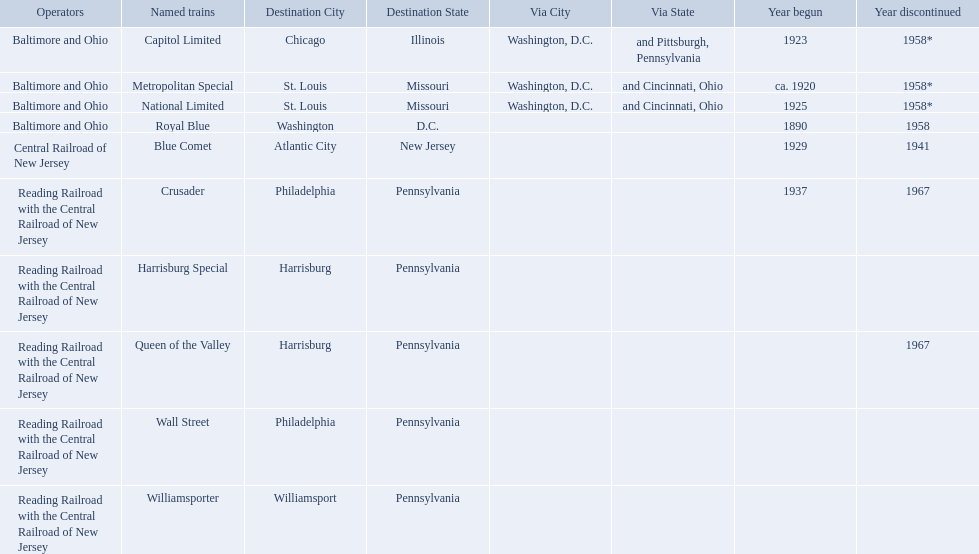What destinations are listed from the central railroad of new jersey terminal? Chicago, Illinois via Washington, D.C. and Pittsburgh, Pennsylvania, St. Louis, Missouri via Washington, D.C. and Cincinnati, Ohio, St. Louis, Missouri via Washington, D.C. and Cincinnati, Ohio, Washington, D.C., Atlantic City, New Jersey, Philadelphia, Pennsylvania, Harrisburg, Pennsylvania, Harrisburg, Pennsylvania, Philadelphia, Pennsylvania, Williamsport, Pennsylvania. Which of these destinations is listed first? Chicago, Illinois via Washington, D.C. and Pittsburgh, Pennsylvania. What are the destinations of the central railroad of new jersey terminal? Chicago, Illinois via Washington, D.C. and Pittsburgh, Pennsylvania, St. Louis, Missouri via Washington, D.C. and Cincinnati, Ohio, St. Louis, Missouri via Washington, D.C. and Cincinnati, Ohio, Washington, D.C., Atlantic City, New Jersey, Philadelphia, Pennsylvania, Harrisburg, Pennsylvania, Harrisburg, Pennsylvania, Philadelphia, Pennsylvania, Williamsport, Pennsylvania. Which of these destinations is at the top of the list? Chicago, Illinois via Washington, D.C. and Pittsburgh, Pennsylvania. Would you mind parsing the complete table? {'header': ['Operators', 'Named trains', 'Destination City', 'Destination State', 'Via City', 'Via State', 'Year begun', 'Year discontinued'], 'rows': [['Baltimore and Ohio', 'Capitol Limited', 'Chicago', 'Illinois', 'Washington, D.C.', 'and Pittsburgh, Pennsylvania', '1923', '1958*'], ['Baltimore and Ohio', 'Metropolitan Special', 'St. Louis', 'Missouri', 'Washington, D.C.', 'and Cincinnati, Ohio', 'ca. 1920', '1958*'], ['Baltimore and Ohio', 'National Limited', 'St. Louis', 'Missouri', 'Washington, D.C.', 'and Cincinnati, Ohio', '1925', '1958*'], ['Baltimore and Ohio', 'Royal Blue', 'Washington', 'D.C.', '', '', '1890', '1958'], ['Central Railroad of New Jersey', 'Blue Comet', 'Atlantic City', 'New Jersey', '', '', '1929', '1941'], ['Reading Railroad with the Central Railroad of New Jersey', 'Crusader', 'Philadelphia', 'Pennsylvania', '', '', '1937', '1967'], ['Reading Railroad with the Central Railroad of New Jersey', 'Harrisburg Special', 'Harrisburg', 'Pennsylvania', '', '', '', ''], ['Reading Railroad with the Central Railroad of New Jersey', 'Queen of the Valley', 'Harrisburg', 'Pennsylvania', '', '', '', '1967'], ['Reading Railroad with the Central Railroad of New Jersey', 'Wall Street', 'Philadelphia', 'Pennsylvania', '', '', '', ''], ['Reading Railroad with the Central Railroad of New Jersey', 'Williamsporter', 'Williamsport', 'Pennsylvania', '', '', '', '']]} 